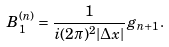Convert formula to latex. <formula><loc_0><loc_0><loc_500><loc_500>B _ { 1 } ^ { ( n ) } = \frac { 1 } { i ( 2 \pi ) ^ { 2 } | \Delta { x } | } g _ { n + 1 } .</formula> 